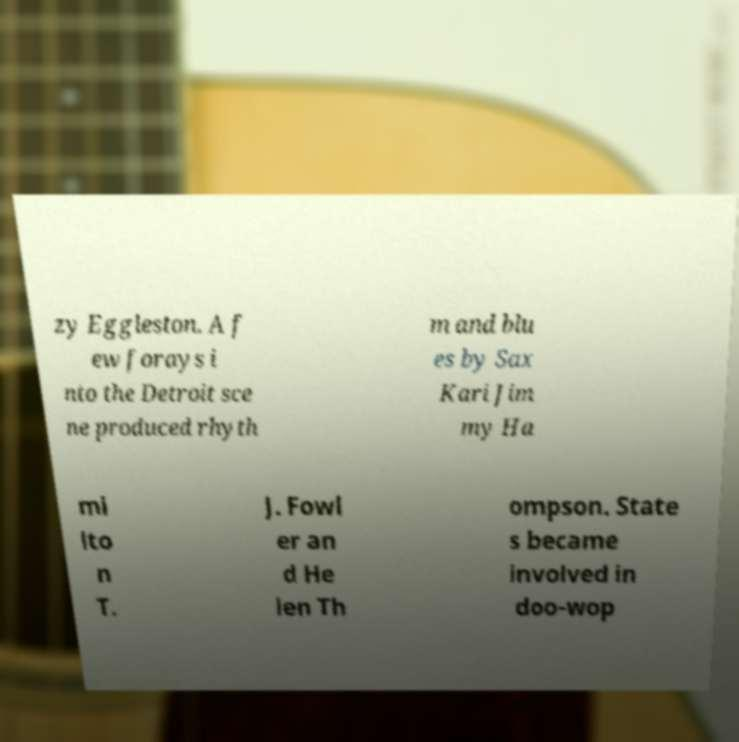Please read and relay the text visible in this image. What does it say? zy Eggleston. A f ew forays i nto the Detroit sce ne produced rhyth m and blu es by Sax Kari Jim my Ha mi lto n T. J. Fowl er an d He len Th ompson. State s became involved in doo-wop 